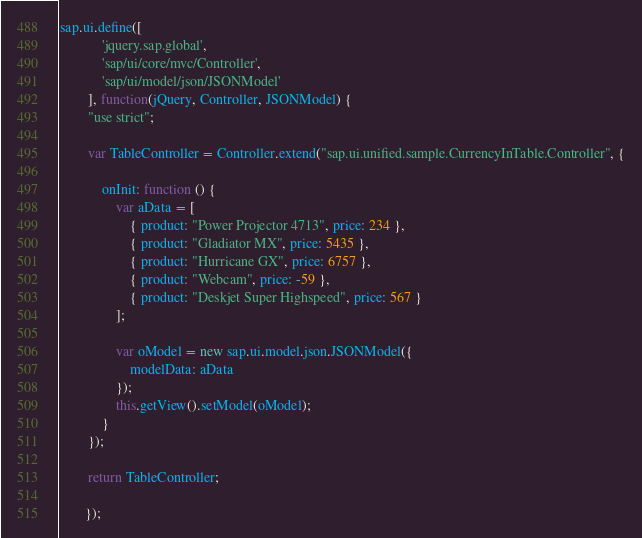<code> <loc_0><loc_0><loc_500><loc_500><_JavaScript_>sap.ui.define([
       		'jquery.sap.global',
       		'sap/ui/core/mvc/Controller',
       		'sap/ui/model/json/JSONModel'
       	], function(jQuery, Controller, JSONModel) {
       	"use strict";

       	var TableController = Controller.extend("sap.ui.unified.sample.CurrencyInTable.Controller", {

       		onInit: function () {
       			var aData = [
       				{ product: "Power Projector 4713", price: 234 },
       				{ product: "Gladiator MX", price: 5435 },
       				{ product: "Hurricane GX", price: 6757 },
       				{ product: "Webcam", price: -59 },
       				{ product: "Deskjet Super Highspeed", price: 567 }
       			];

       			var oModel = new sap.ui.model.json.JSONModel({
       				modelData: aData
       			});
       			this.getView().setModel(oModel);
       		}
       	});

       	return TableController;

       });</code> 